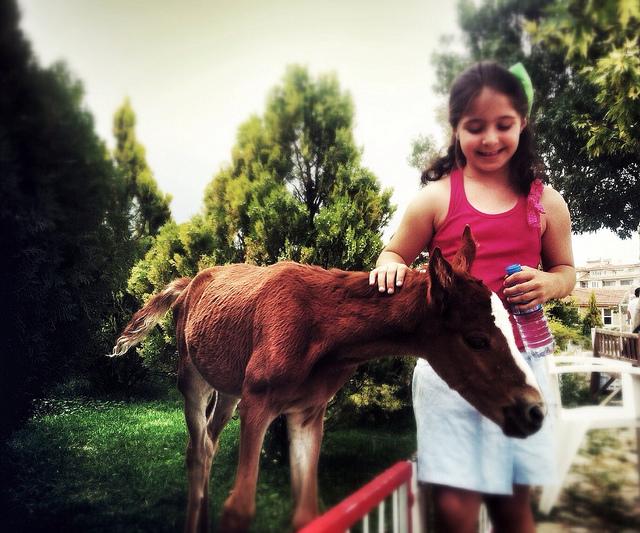What is the name of the marking on the horse's face?
Concise answer only. Stripe. What is standing beside the horse?
Write a very short answer. Girl. Which hand has a water bottle?
Concise answer only. Left. 